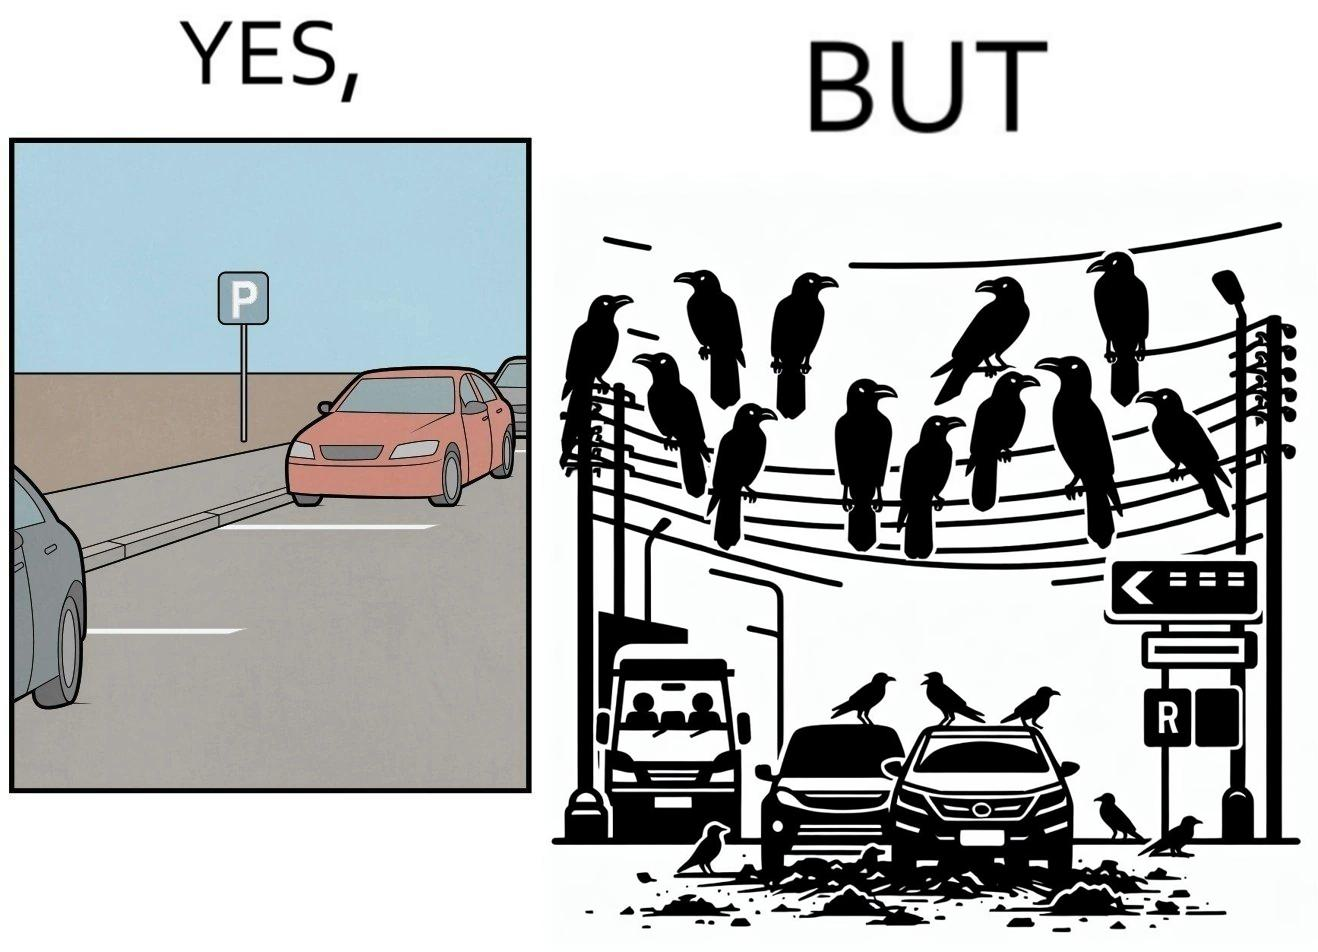What is shown in this image? The image is ironical such that although there is a place for parking but that place is not suitable because if we place our car there then our car will become dirty from top due to crow beet. 